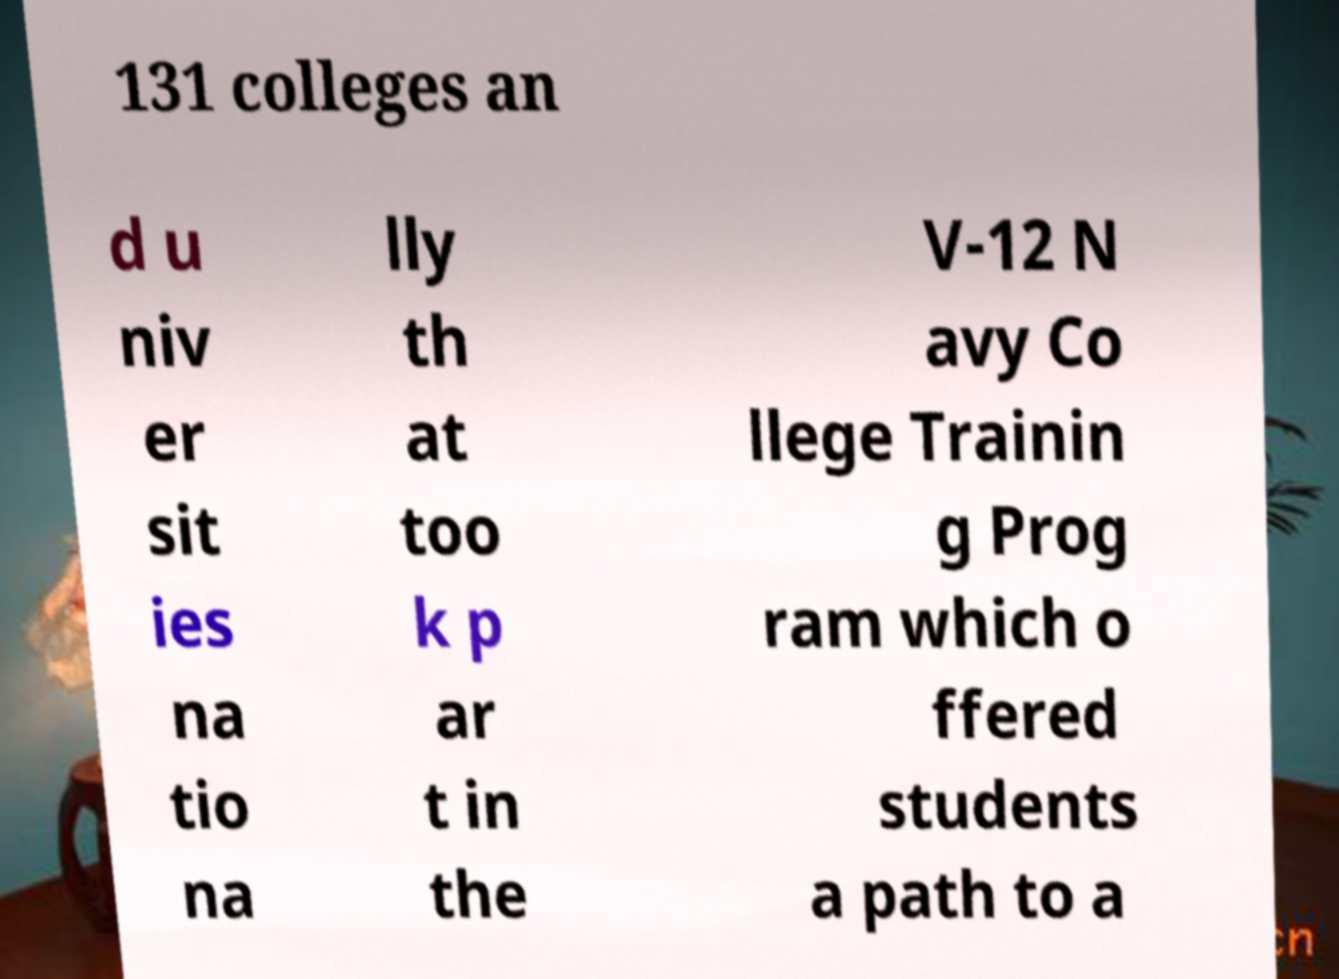I need the written content from this picture converted into text. Can you do that? 131 colleges an d u niv er sit ies na tio na lly th at too k p ar t in the V-12 N avy Co llege Trainin g Prog ram which o ffered students a path to a 